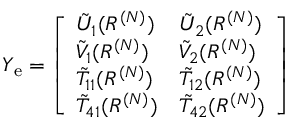<formula> <loc_0><loc_0><loc_500><loc_500>\begin{array} { r } { Y _ { e } = \left [ \begin{array} { l l } { \tilde { U } _ { 1 } ( R ^ { ( N ) } ) } & { \tilde { U } _ { 2 } ( R ^ { ( N ) } ) } \\ { \tilde { V } _ { 1 } ( R ^ { ( N ) } ) } & { \tilde { V } _ { 2 } ( R ^ { ( N ) } ) } \\ { \tilde { T } _ { 1 1 } ( R ^ { ( N ) } ) } & { \tilde { T } _ { 1 2 } ( R ^ { ( N ) } ) } \\ { \tilde { T } _ { 4 1 } ( R ^ { ( N ) } ) } & { \tilde { T } _ { 4 2 } ( R ^ { ( N ) } ) } \end{array} \right ] } \end{array}</formula> 